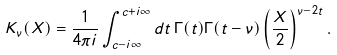<formula> <loc_0><loc_0><loc_500><loc_500>K _ { \nu } ( X ) = \frac { 1 } { 4 \pi i } \int _ { c - i \infty } ^ { c + i \infty } d t \, \Gamma ( t ) \Gamma ( t - \nu ) \left ( \frac { X } { 2 } \right ) ^ { \nu - 2 t } .</formula> 